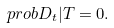<formula> <loc_0><loc_0><loc_500><loc_500>\ p r o b { D _ { t } | T } = 0 .</formula> 